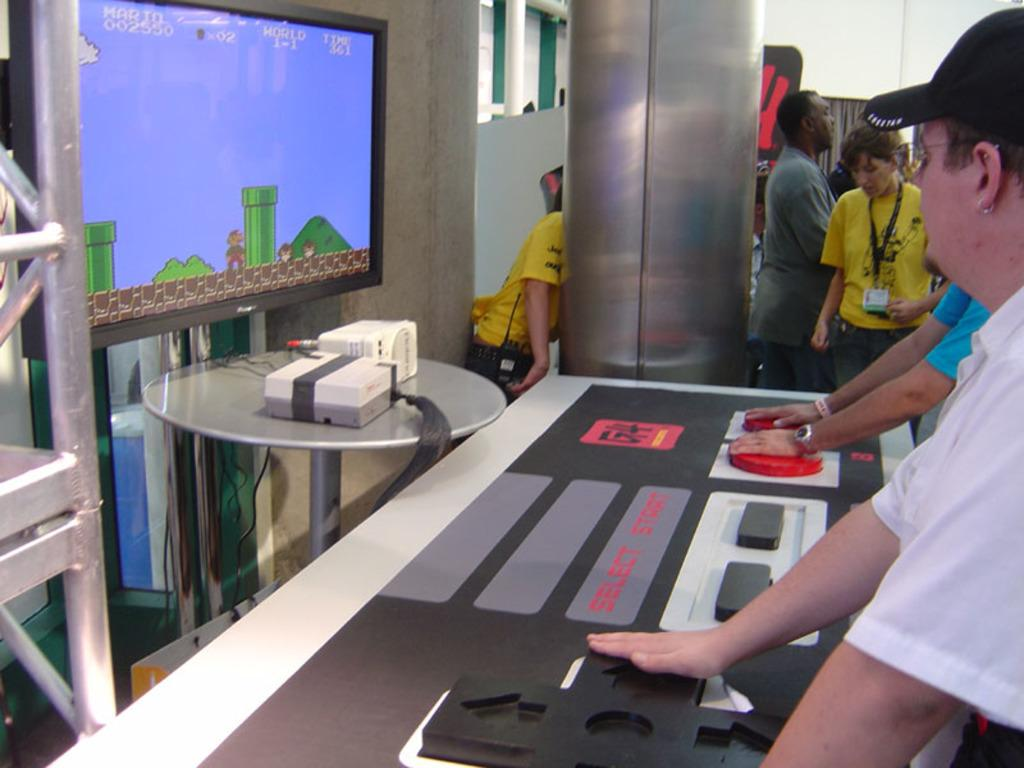What is present in the image? There is a man and a television screen in the image. Can you describe the man in the image? The facts provided do not give any details about the man's appearance or actions. What is the television screen showing in the image? The facts provided do not give any details about what is on the television screen. What type of offer is the man making to the audience on the television screen? There is no information about the man making an offer or the television screen showing an audience, so this question cannot be answered definitively. 